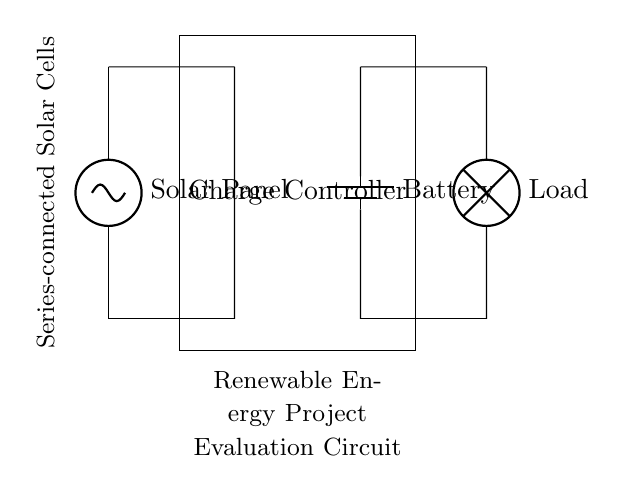What components are in this circuit? The circuit contains a solar panel, a charge controller, a battery, and a load. Each component can be visually identified in the diagram with their corresponding labels.
Answer: solar panel, charge controller, battery, load What is the role of the charge controller in this circuit? The charge controller regulates the voltage and current from the solar panel to the battery, preventing overcharging. It is essential for ensuring that the battery operates safely and efficiently with sustainable energy input.
Answer: regulate voltage and current How are the solar cells connected in this circuit? The solar cells are connected in series, indicated by the label in the diagram and their arrangement that implies a sequential connection. In a series arrangement, the output voltage from each cell adds up while the current remains the same.
Answer: series What would happen if the battery was disconnected? If the battery is disconnected, there would be no energy storage, and the load would not receive any power from the solar panel, resulting in a non-functional system since the circuit would be incomplete.
Answer: load loses power What is the potential advantage of using series-connected solar cells? The advantage of series-connected solar cells is that the voltage output increases with each additional cell added in the configuration, allowing for a higher total voltage that can be utilized for charging the battery effectively.
Answer: increased voltage output What does the lamp represent in this circuit? The lamp represents the load that consumes energy from the battery, demonstrating the practical application of the stored solar energy in a real-world scenario. It visualizes how the system powers an electrical device.
Answer: load What is the significance of renewable energy evaluation in the circuit diagram? The significance lies in assessing the efficiency and functionality of the system in harnessing solar energy, providing insights that can guide future renewable energy investments and adaptations in the Middle East context.
Answer: investment assessment 